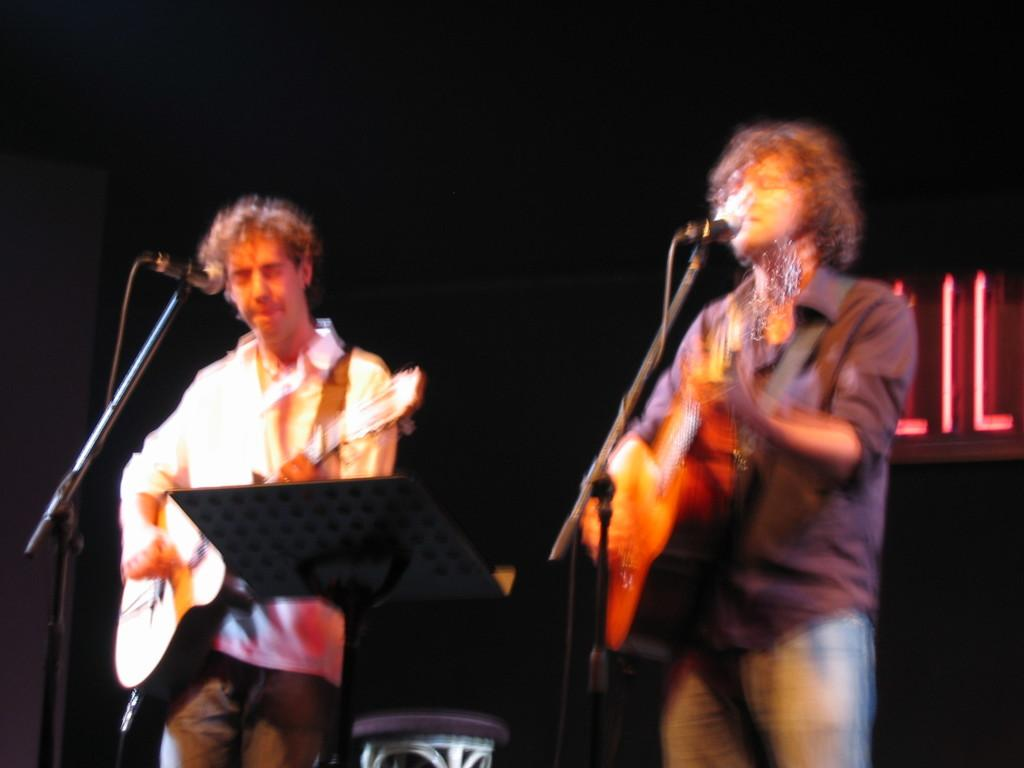How many people are in the image? There are two men in the image. What are the men holding in the image? The men are holding guitars in the image. How are the men holding the guitars? The men are holding the guitars with their hands. What is in front of the men? There are microphones and a stand in front of the men. What is the color of the background in the image? The background of the image is dark. What type of haircut does the man on the left have in the image? There is no information about the men's haircuts in the image. What arithmetic problem can be solved using the numbers on the stand in front of the men? There are no numbers visible on the stand in the image. 